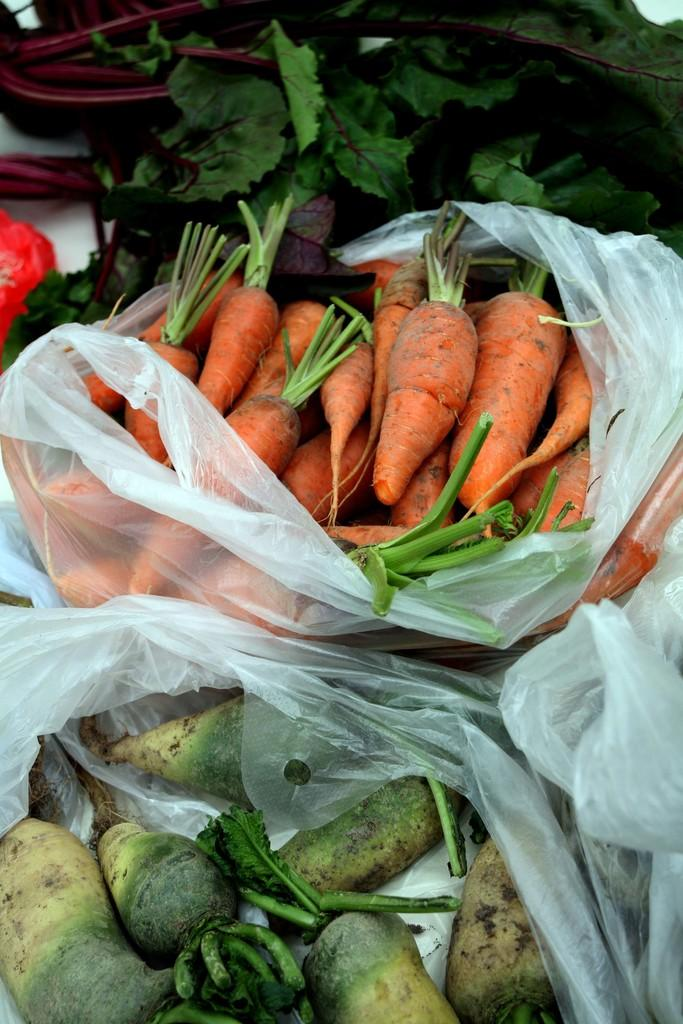What type of vegetables can be seen in the image? There are leafy vegetables, carrots, and beetroots in the image. What fruit is present in the image? There is a strawberry in the image. Are all the vegetables and fruit visible or covered? The vegetables, strawberry, carrots, and beetroots are covered. What is the aftermath of the town's decision in the image? There is no mention of a town or decision in the image, so it is not possible to answer that question. 